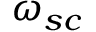Convert formula to latex. <formula><loc_0><loc_0><loc_500><loc_500>\omega _ { s c }</formula> 